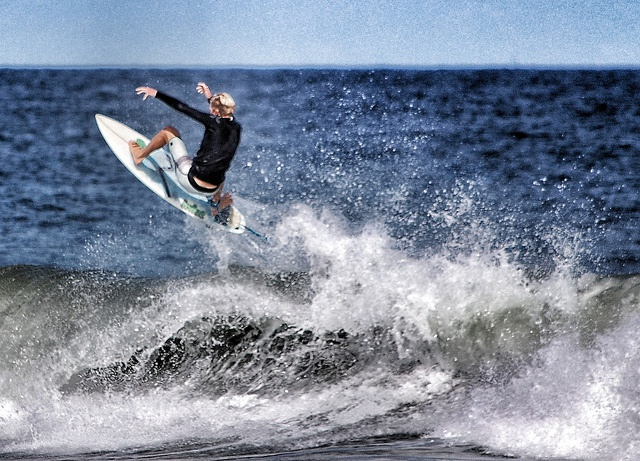Describe the objects in this image and their specific colors. I can see people in lightblue, black, lightgray, gray, and darkgray tones and surfboard in lightblue, white, darkgray, and gray tones in this image. 